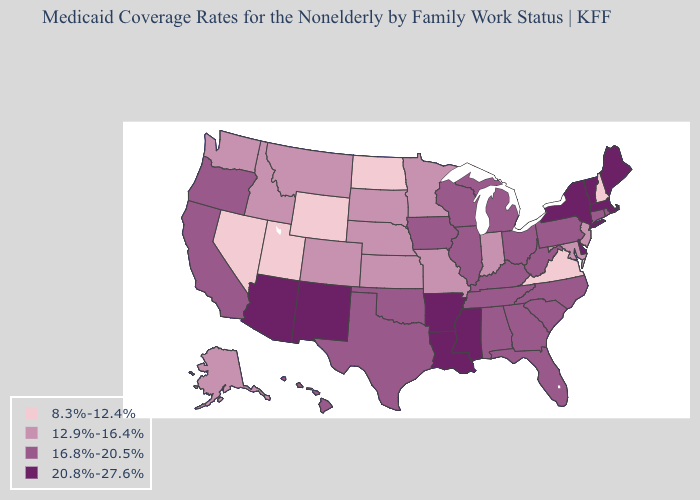What is the lowest value in the Northeast?
Answer briefly. 8.3%-12.4%. What is the lowest value in the Northeast?
Keep it brief. 8.3%-12.4%. What is the lowest value in the USA?
Write a very short answer. 8.3%-12.4%. Which states have the highest value in the USA?
Concise answer only. Arizona, Arkansas, Delaware, Louisiana, Maine, Massachusetts, Mississippi, New Mexico, New York, Vermont. What is the value of New Jersey?
Be succinct. 12.9%-16.4%. Name the states that have a value in the range 12.9%-16.4%?
Quick response, please. Alaska, Colorado, Idaho, Indiana, Kansas, Maryland, Minnesota, Missouri, Montana, Nebraska, New Jersey, South Dakota, Washington. What is the value of Nebraska?
Write a very short answer. 12.9%-16.4%. What is the value of West Virginia?
Be succinct. 16.8%-20.5%. What is the lowest value in the USA?
Short answer required. 8.3%-12.4%. Does Georgia have the same value as New Jersey?
Short answer required. No. What is the highest value in states that border Utah?
Write a very short answer. 20.8%-27.6%. What is the lowest value in the Northeast?
Be succinct. 8.3%-12.4%. Does Ohio have the same value as Nevada?
Give a very brief answer. No. Does the first symbol in the legend represent the smallest category?
Be succinct. Yes. Among the states that border Arizona , which have the highest value?
Give a very brief answer. New Mexico. 